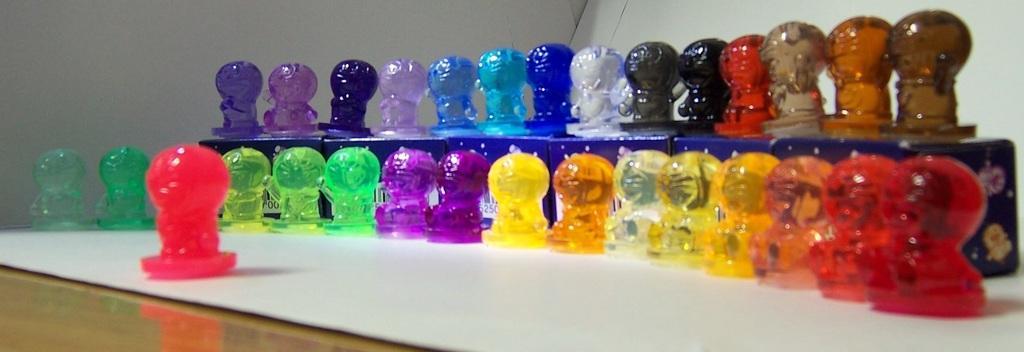In one or two sentences, can you explain what this image depicts? In this picture, we see many glass toys are placed on the white table. Behind that, we see the same glass toys are placed on the blue color boxes. These toys are in purple, red, green, orange, black, brown and blue color. In the background, we see a white wall. 